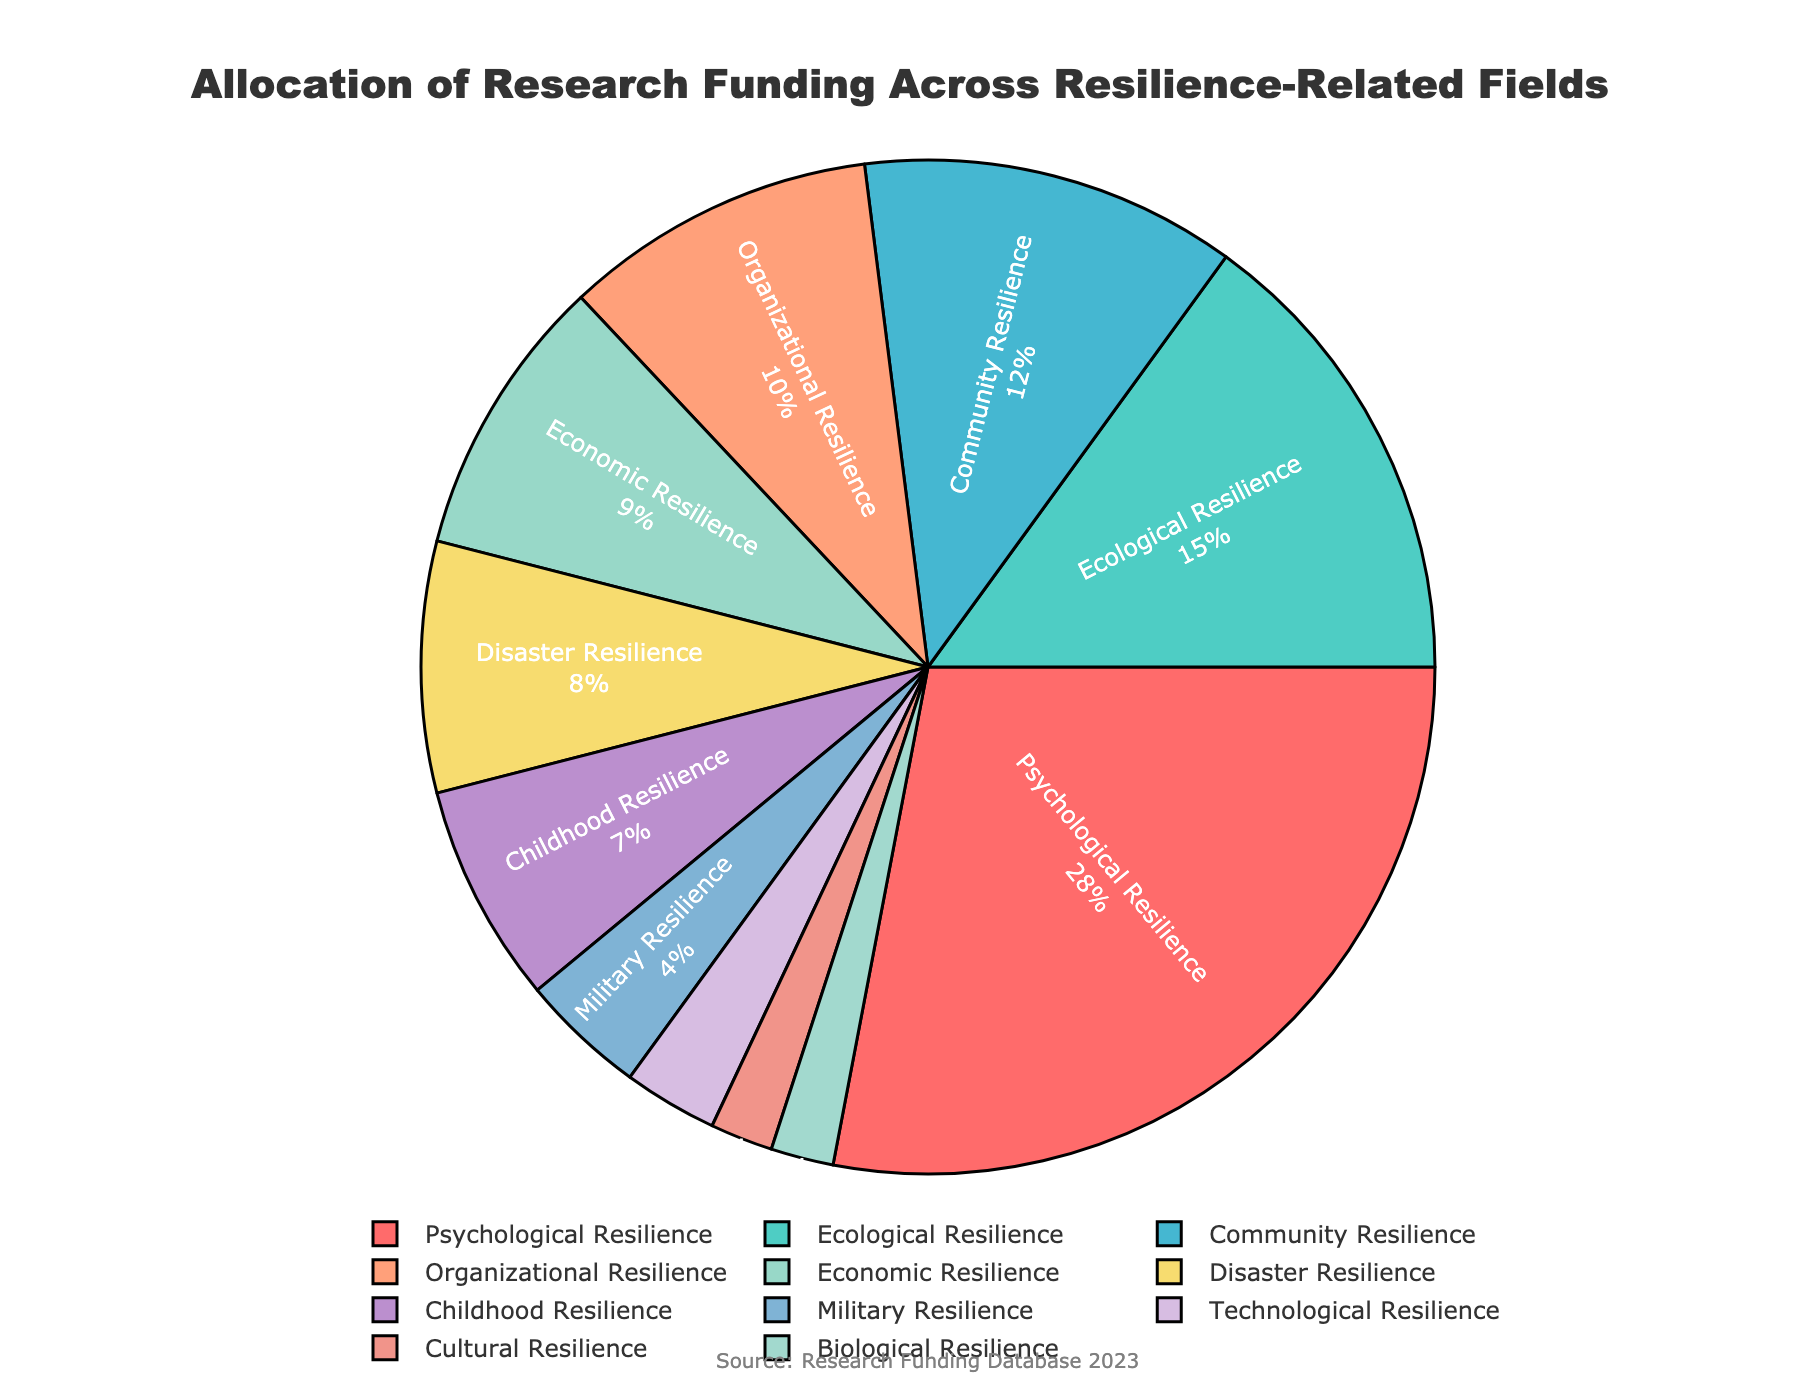Which field received the highest percentage of research funding? The pie chart shows the distribution of funding across various fields. "Psychological Resilience" has the highest percentage of funding, clearly visible as the largest segment, labeled with 28%.
Answer: Psychological Resilience What is the combined funding percentage for Economic Resilience and Organizational Resilience? To find the combined percentage, add the funding percentages for both fields: 9% for Economic Resilience and 10% for Organizational Resilience. Thus, 9% + 10% = 19%.
Answer: 19% Which field has a larger funding allocation: Community Resilience or Disaster Resilience? Look at the pie chart segments for both fields and compare their percentages. Community Resilience has 12%, while Disaster Resilience has 8%. 12% is larger than 8%.
Answer: Community Resilience How much more funding does Psychological Resilience receive compared to Childhood Resilience? Subtract the funding percentage for Childhood Resilience from that for Psychological Resilience: 28% - 7% = 21%.
Answer: 21% Are there any fields with equal funding percentages? If so, which ones? Observe the pie chart for fields with identical percentage labels. Both Technological Resilience and Biological Resilience have a funding percentage of 2%.
Answer: Technological Resilience and Biological Resilience Which field is represented by the smallest segment, and what is its percentage? Identify the smallest segment in the pie chart. "Cultural Resilience" is the smallest segment, labeled with 2%.
Answer: Cultural Resilience, 2% What is the total funding percentage for the fields with less than 5% allocation each? Sum the percentages for all fields with less than 5% funding: Military Resilience (4%), Technological Resilience (3%), Cultural Resilience (2%), Biological Resilience (2%). So, 4% + 3% + 2% + 2% = 11%.
Answer: 11% Which field received double the funding compared to Disaster Resilience? Determine the funding percentage for Disaster Resilience (8%) and find the field with double this amount. 8% * 2 = 16%, but no field exactly matches this, so check the closest higher category. "Ecological Resilience" received 15%, which is the closest substantial funding above double.
Answer: Ecological Resilience If we combined Organizational Resilience and Community Resilience, what would their joint funding percentage be? Would this create a new second-largest segment? Combine the percentages for Organizational Resilience (10%) and Community Resilience (12%): 10% + 12% = 22%. Compare 22% to the second largest segment, Ecological Resilience at 15%. With 22%, the combination would indeed be the new second-largest segment.
Answer: 22%, Yes 